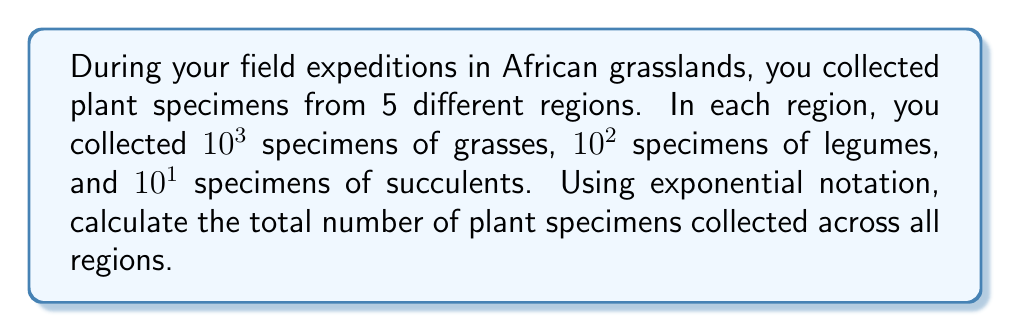What is the answer to this math problem? Let's approach this step-by-step:

1) First, let's calculate the number of specimens collected in one region:
   Grasses: $10^3 = 1000$
   Legumes: $10^2 = 100$
   Succulents: $10^1 = 10$
   
   Total per region: $1000 + 100 + 10 = 1110$

2) We can express this as: $1.11 \times 10^3$

3) Now, we need to multiply this by the number of regions (5):
   $5 \times (1.11 \times 10^3)$

4) Using the properties of exponents, we can rewrite this as:
   $(5 \times 1.11) \times 10^3$

5) Calculating:
   $5.55 \times 10^3$

Therefore, the total number of specimens collected across all 5 regions, expressed in exponential notation, is $5.55 \times 10^3$.
Answer: $5.55 \times 10^3$ 